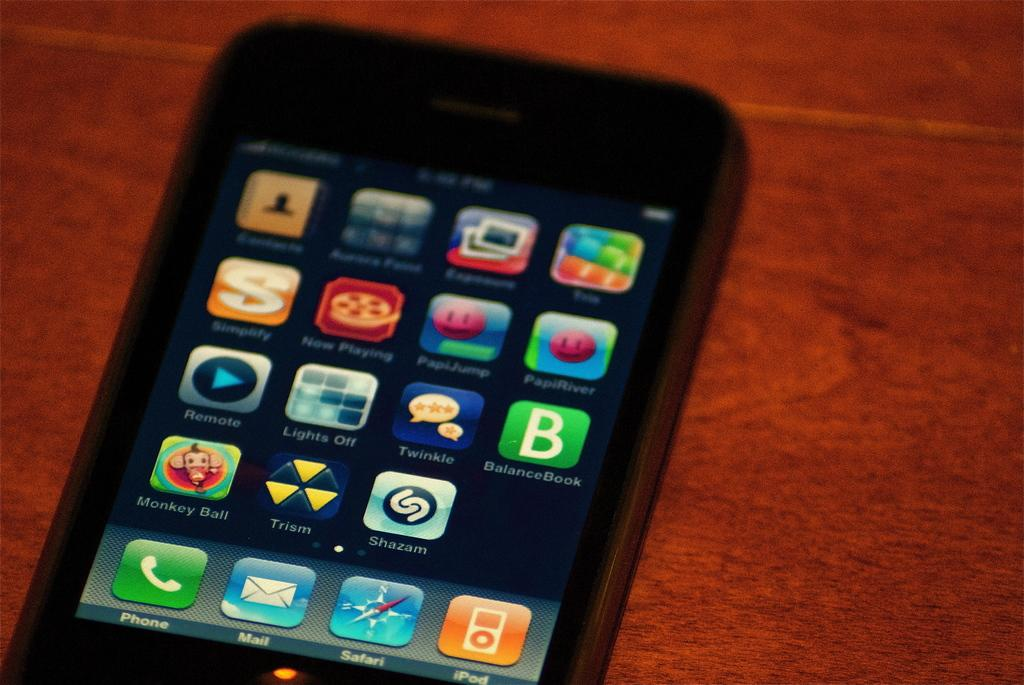<image>
Offer a succinct explanation of the picture presented. A phone screen showing apps such as Monkey Ball 